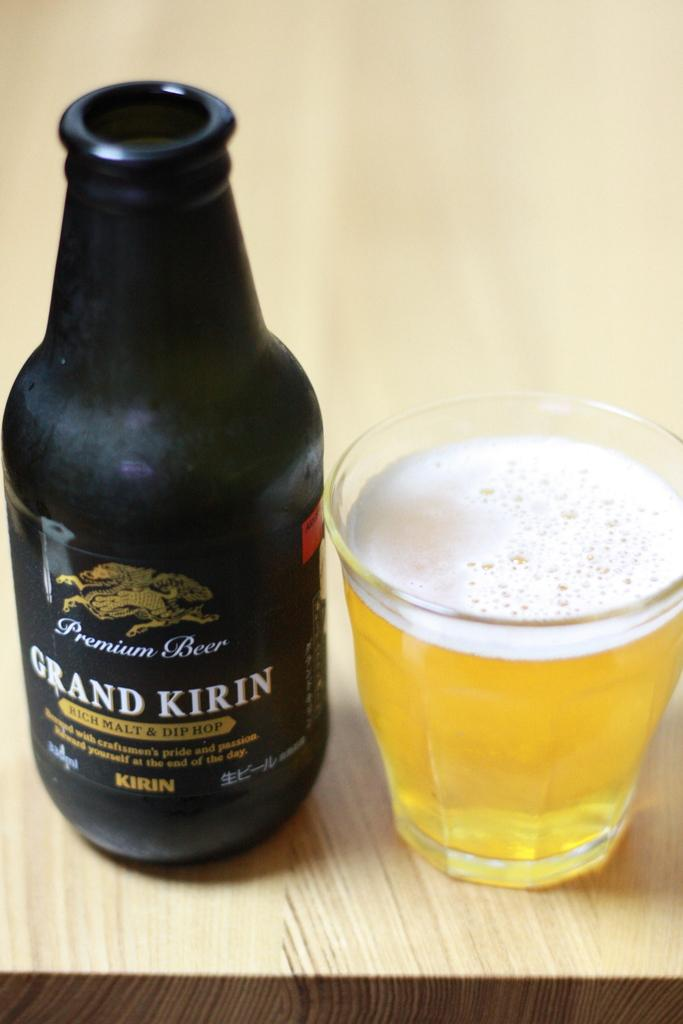<image>
Write a terse but informative summary of the picture. A black bottle of Grand Kirin Malt next to a full glass of beer. 